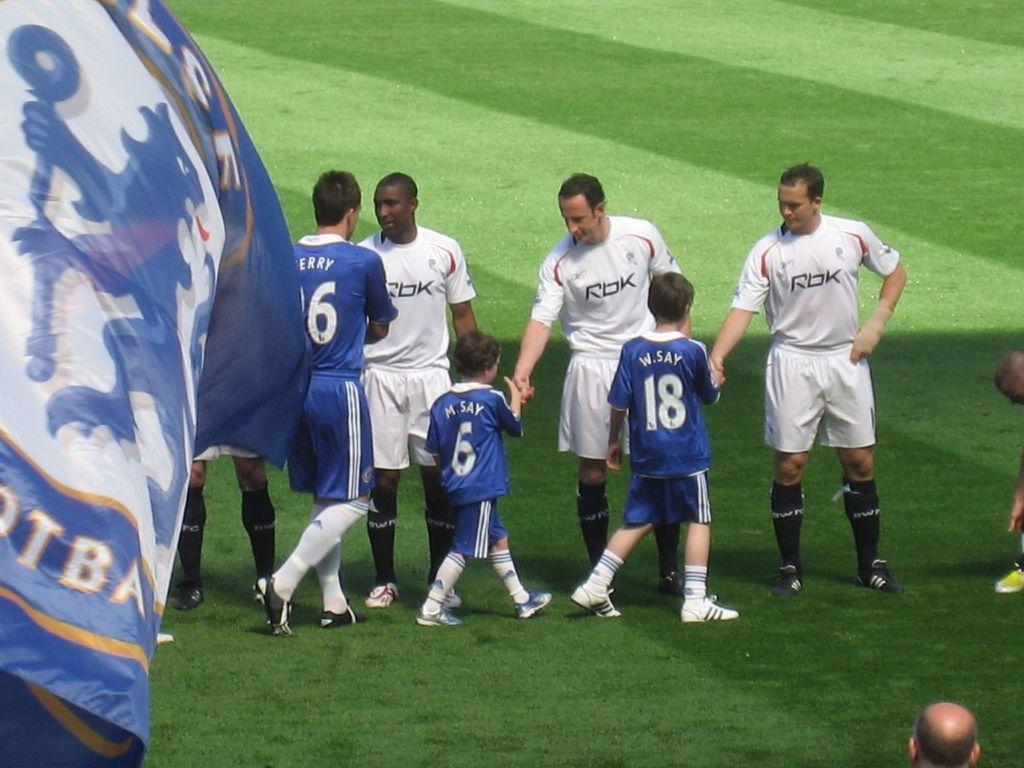What is happening in the center of the image? There are people standing in the center of the image. Can you describe the age group of the people in the image? There are kids in the image. What can be seen at the bottom of the image? The ground is visible at the bottom of the image. What is on the left side of the image? There is a banner on the left side of the image. What type of steel is used to make the duck in the image? There is no duck present in the image, and therefore no steel can be associated with it. Can you hear the whistle in the image? There is no whistle present in the image, so it cannot be heard. 